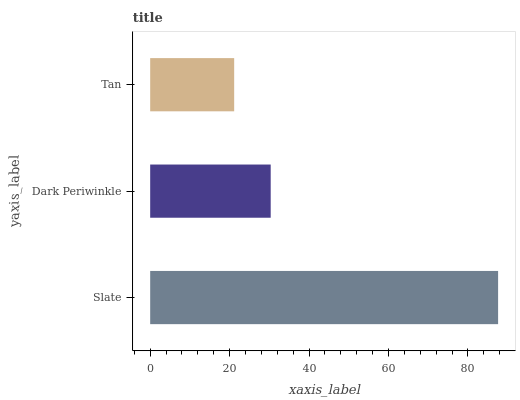Is Tan the minimum?
Answer yes or no. Yes. Is Slate the maximum?
Answer yes or no. Yes. Is Dark Periwinkle the minimum?
Answer yes or no. No. Is Dark Periwinkle the maximum?
Answer yes or no. No. Is Slate greater than Dark Periwinkle?
Answer yes or no. Yes. Is Dark Periwinkle less than Slate?
Answer yes or no. Yes. Is Dark Periwinkle greater than Slate?
Answer yes or no. No. Is Slate less than Dark Periwinkle?
Answer yes or no. No. Is Dark Periwinkle the high median?
Answer yes or no. Yes. Is Dark Periwinkle the low median?
Answer yes or no. Yes. Is Slate the high median?
Answer yes or no. No. Is Tan the low median?
Answer yes or no. No. 